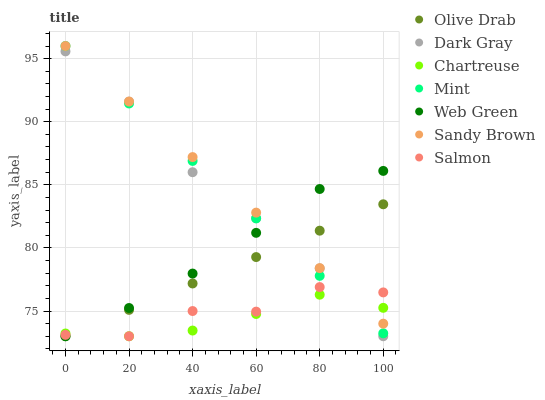Does Chartreuse have the minimum area under the curve?
Answer yes or no. Yes. Does Sandy Brown have the maximum area under the curve?
Answer yes or no. Yes. Does Salmon have the minimum area under the curve?
Answer yes or no. No. Does Salmon have the maximum area under the curve?
Answer yes or no. No. Is Olive Drab the smoothest?
Answer yes or no. Yes. Is Salmon the roughest?
Answer yes or no. Yes. Is Web Green the smoothest?
Answer yes or no. No. Is Web Green the roughest?
Answer yes or no. No. Does Salmon have the lowest value?
Answer yes or no. Yes. Does Sandy Brown have the lowest value?
Answer yes or no. No. Does Sandy Brown have the highest value?
Answer yes or no. Yes. Does Salmon have the highest value?
Answer yes or no. No. Is Dark Gray less than Sandy Brown?
Answer yes or no. Yes. Is Sandy Brown greater than Dark Gray?
Answer yes or no. Yes. Does Chartreuse intersect Mint?
Answer yes or no. Yes. Is Chartreuse less than Mint?
Answer yes or no. No. Is Chartreuse greater than Mint?
Answer yes or no. No. Does Dark Gray intersect Sandy Brown?
Answer yes or no. No. 